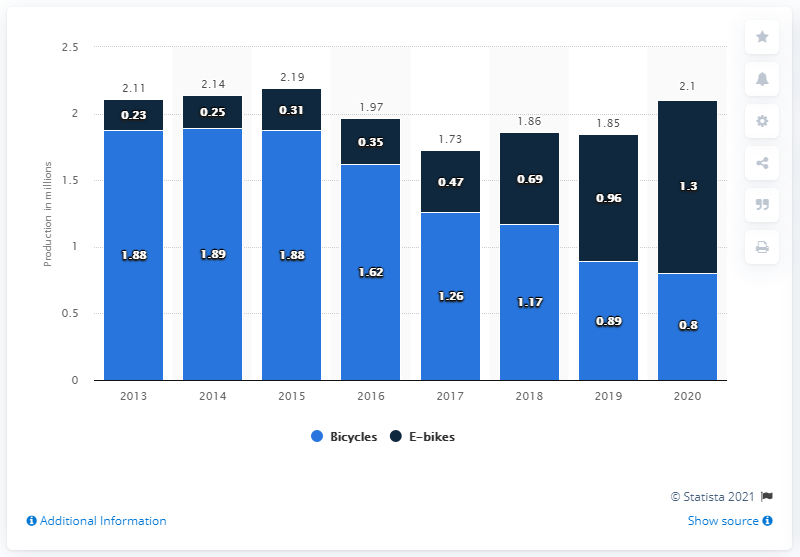Identify some key points in this picture. In 2020, German manufacturers produced a total of 1,300 units of electric bicycles. 